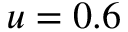Convert formula to latex. <formula><loc_0><loc_0><loc_500><loc_500>u = 0 . 6</formula> 